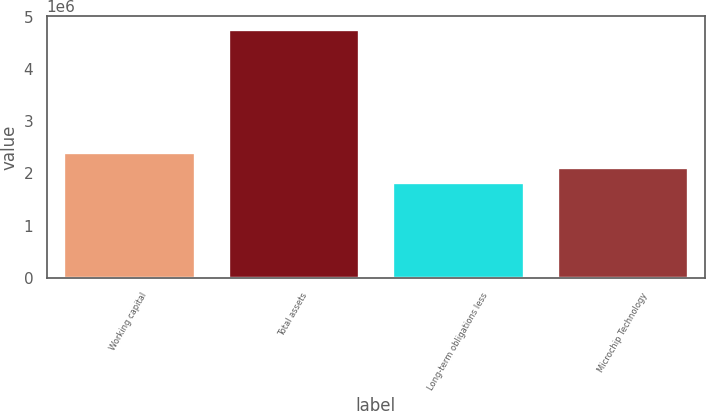Convert chart to OTSL. <chart><loc_0><loc_0><loc_500><loc_500><bar_chart><fcel>Working capital<fcel>Total assets<fcel>Long-term obligations less<fcel>Microchip Technology<nl><fcel>2.41763e+06<fcel>4.78071e+06<fcel>1.82686e+06<fcel>2.12224e+06<nl></chart> 